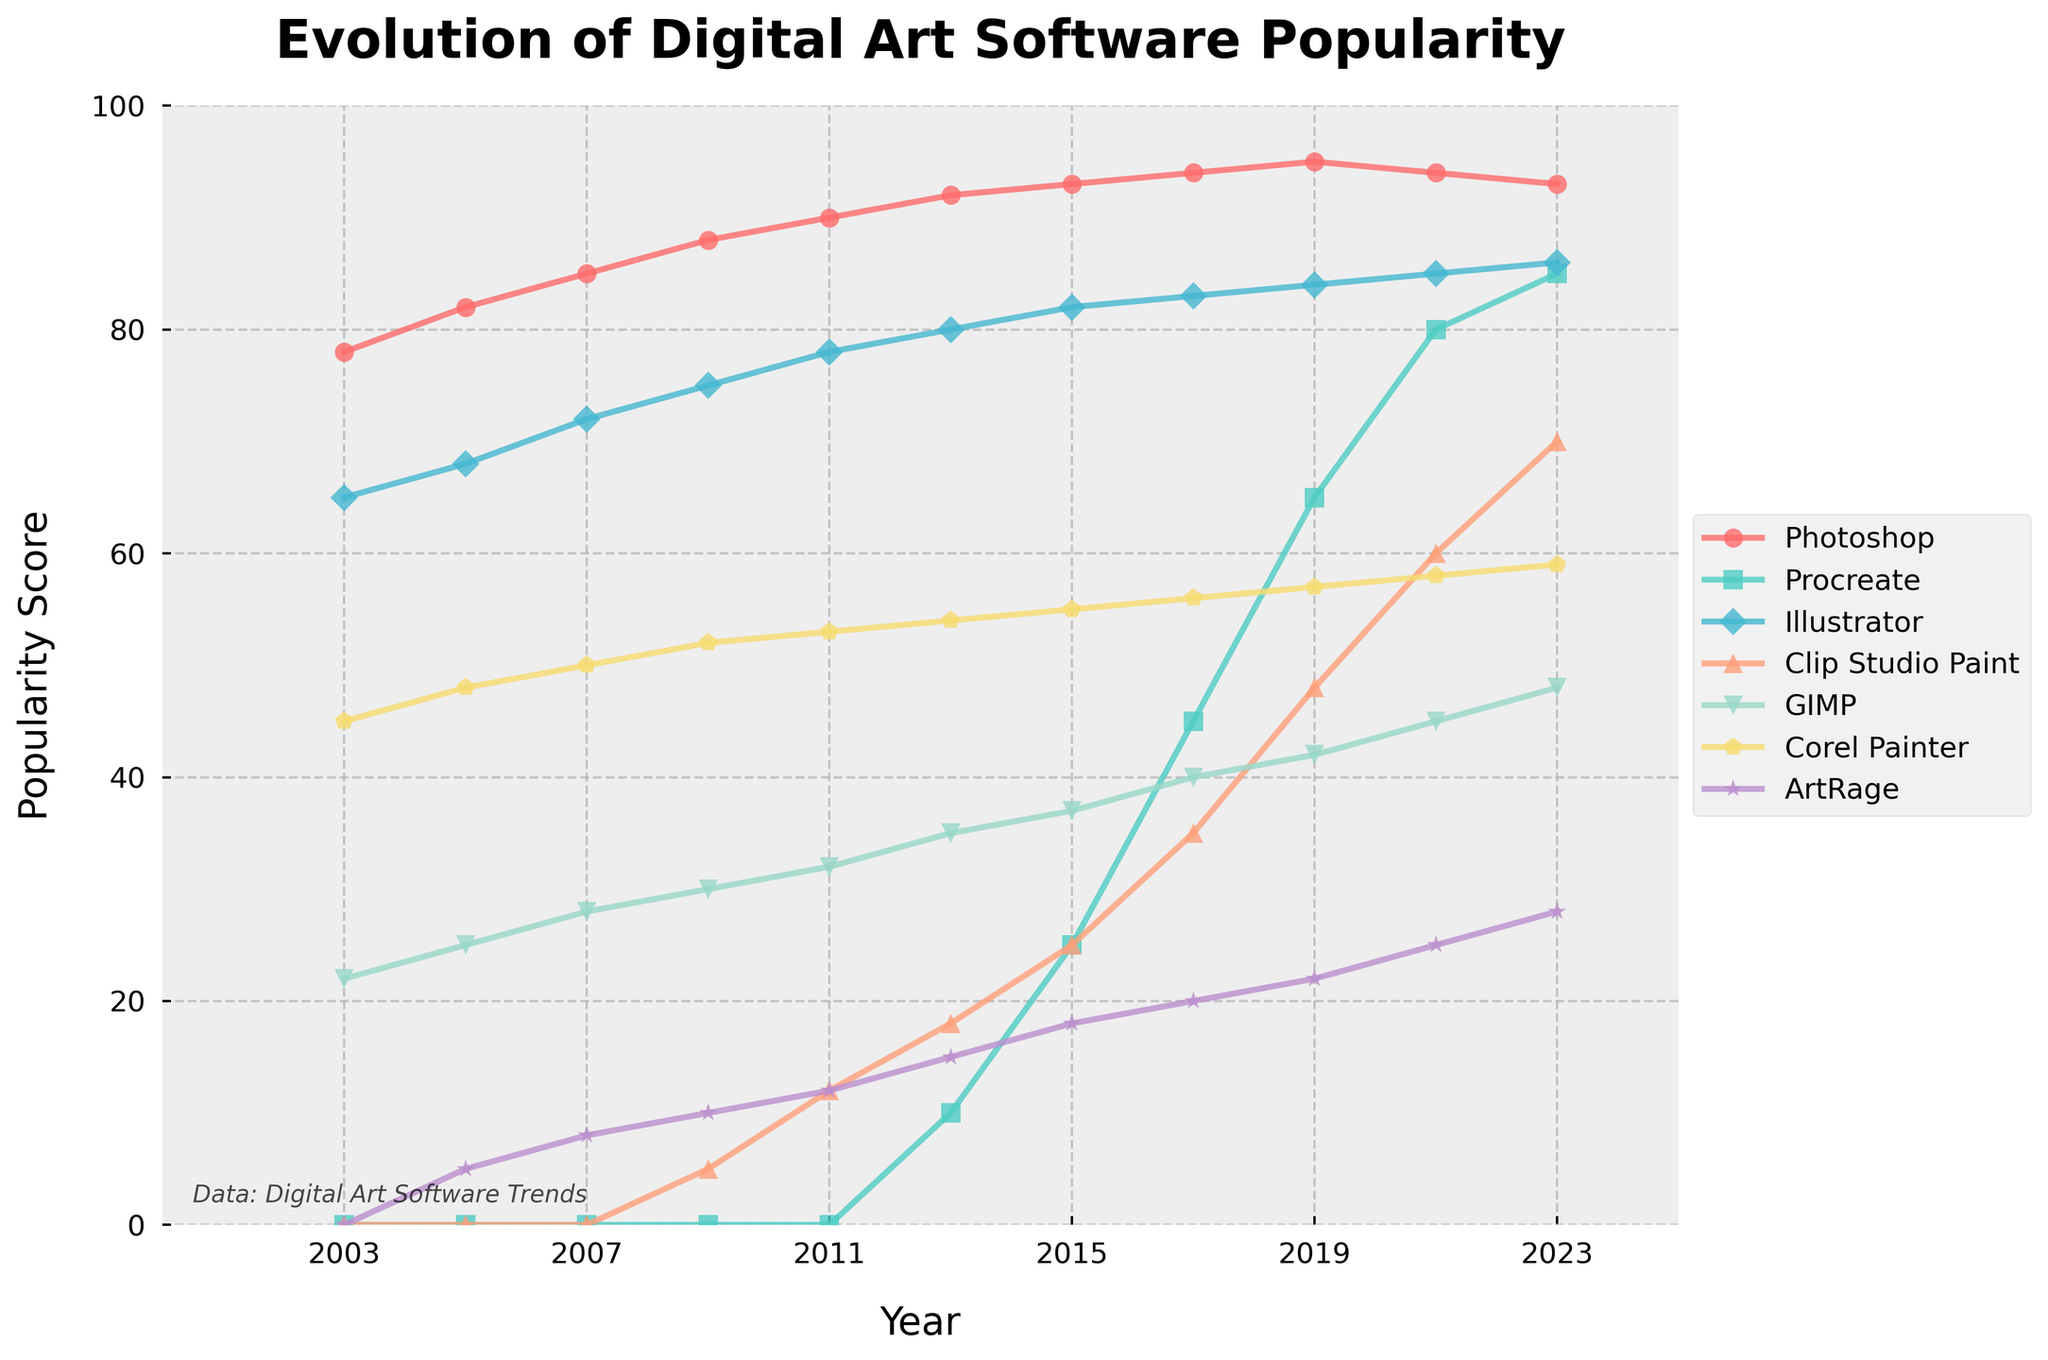Which software had the highest popularity score in 2023? By looking at the chart, each software's trend line and markers for 2023 can be compared. The highest marker represents the software with the highest popularity, which is Illustrator.
Answer: Illustrator What is the difference in popularity between Photoshop and Procreate in 2019? Identify the points on the graph for Photoshop and Procreate in 2019. Photoshop has a popularity score of 95, and Procreate is at 65. Subtract the smaller score from the larger score: 95 - 65 = 30.
Answer: 30 Which trend line shows the most significant increase in popularity from 2003 to 2023? Compare the lines to see which one rises the most from the left (2003) to the right (2023). Procreate shows the most significant increase, going from 0 in 2003 to 85 in 2023.
Answer: Procreate How many pieces of software have a popularity score of more than 50 in 2023? Check the graph for all software marks in 2023 and count those with a score above 50. The scores above 50 in 2023 are Photoshop, Procreate, Illustrator, Clip Studio Paint, and Corel Painter, making a total of 5.
Answer: 5 For which years did Photoshop have a higher popularity score than 90? Look at the trend line for Photoshop and observe the years where it crosses above 90. Photoshop's popularity score was higher than 90 for the years 2011, 2013, 2015, 2017, and 2019.
Answer: 2011, 2013, 2015, 2017, 2019 What is the average popularity of Clip Studio Paint in 2021 and 2023? Locate the scores for Clip Studio Paint in 2021 and 2023; they are 60 and 70. Calculate the average: (60 + 70) / 2 = 65.
Answer: 65 Which software has the least change in popularity from 2003 to 2023? Compare the start and end points of each trend line to see which has the smallest change. GIMP's scores changed from 22 in 2003 to 48 in 2023, showing the smallest change of 26 points.
Answer: GIMP Which software surpassed a popularity score of 50 first? Find the trend line that reaches above the 50 mark the earliest according to the timeline. Photoshop was the first to surpass 50, which it did before the year 2003.
Answer: Photoshop What is the combined popularity score of Corel Painter and ArtRage in 2015? Find the scores for Corel Painter and ArtRage in 2015. Corel Painter is 55 and ArtRage is 18. Add them together: 55 + 18 = 73.
Answer: 73 